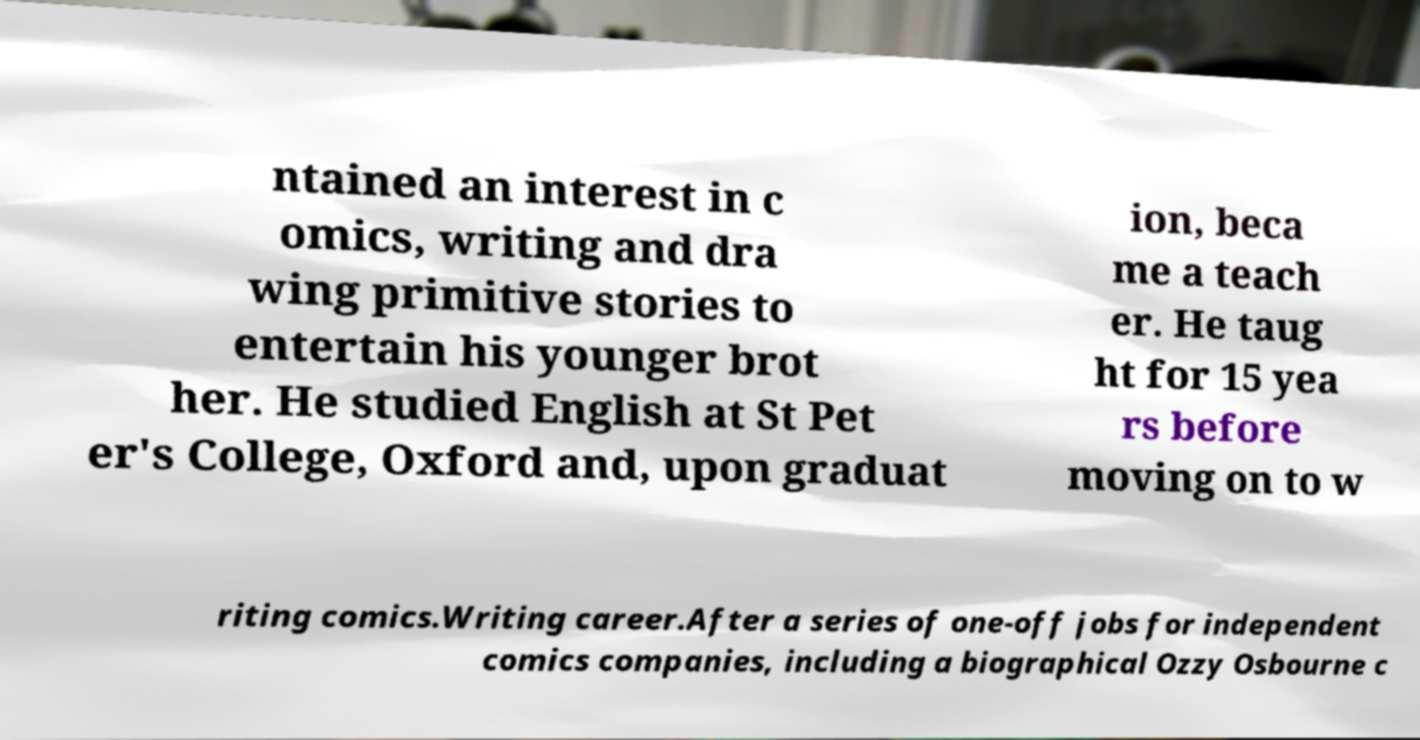What messages or text are displayed in this image? I need them in a readable, typed format. ntained an interest in c omics, writing and dra wing primitive stories to entertain his younger brot her. He studied English at St Pet er's College, Oxford and, upon graduat ion, beca me a teach er. He taug ht for 15 yea rs before moving on to w riting comics.Writing career.After a series of one-off jobs for independent comics companies, including a biographical Ozzy Osbourne c 